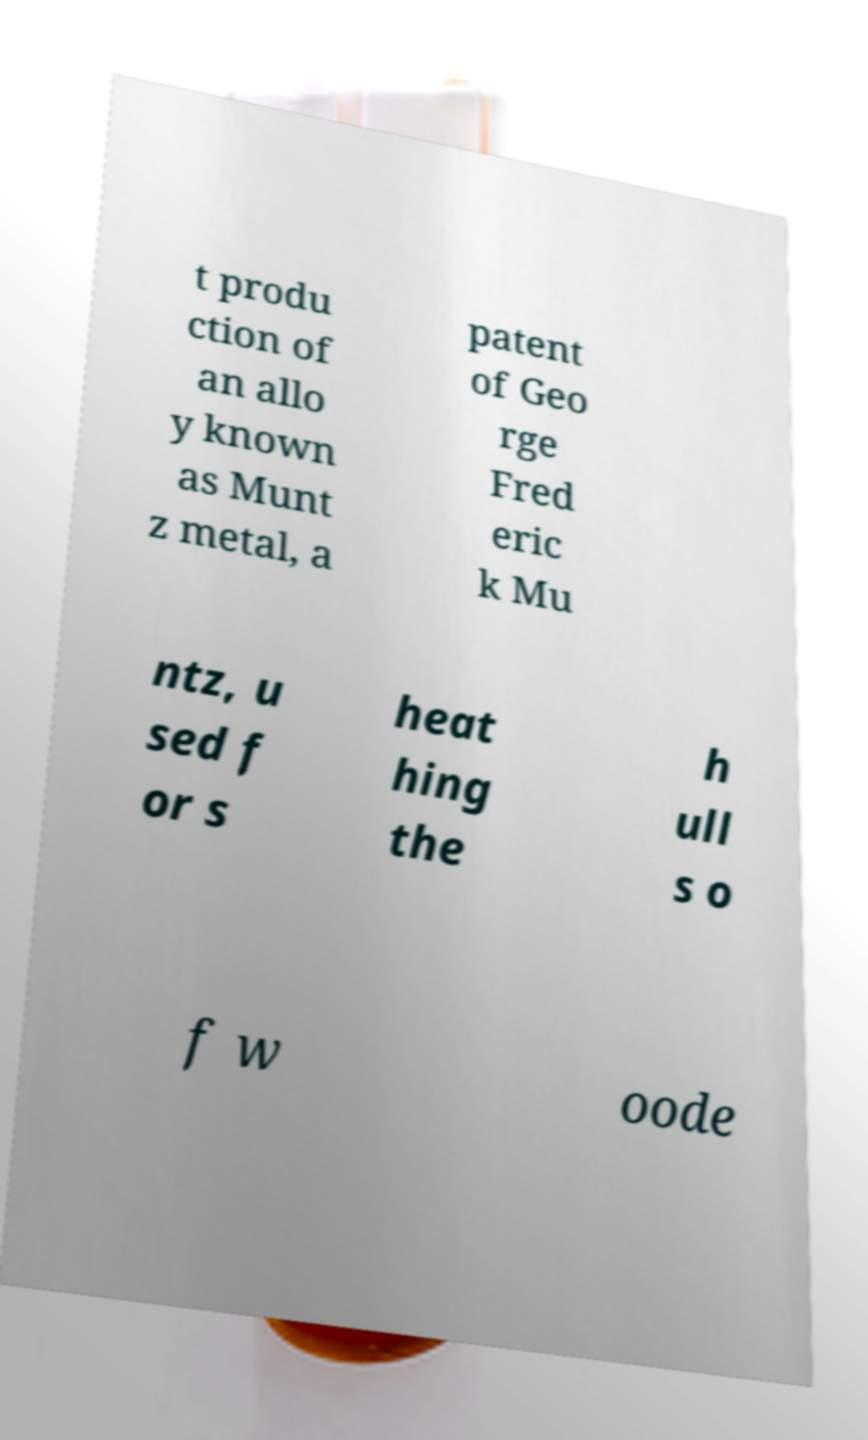Please read and relay the text visible in this image. What does it say? t produ ction of an allo y known as Munt z metal, a patent of Geo rge Fred eric k Mu ntz, u sed f or s heat hing the h ull s o f w oode 